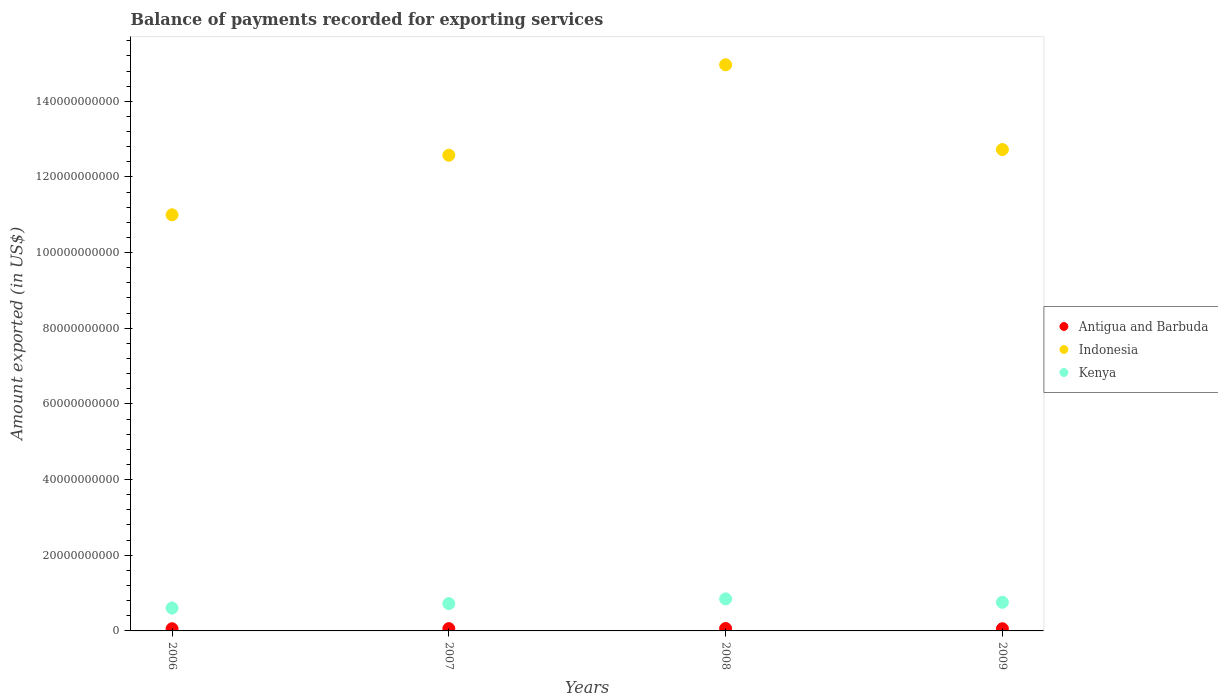How many different coloured dotlines are there?
Your response must be concise. 3. Is the number of dotlines equal to the number of legend labels?
Ensure brevity in your answer.  Yes. What is the amount exported in Indonesia in 2008?
Your answer should be compact. 1.50e+11. Across all years, what is the maximum amount exported in Antigua and Barbuda?
Offer a very short reply. 6.41e+08. Across all years, what is the minimum amount exported in Indonesia?
Provide a short and direct response. 1.10e+11. In which year was the amount exported in Kenya minimum?
Keep it short and to the point. 2006. What is the total amount exported in Kenya in the graph?
Your answer should be compact. 2.93e+1. What is the difference between the amount exported in Antigua and Barbuda in 2007 and that in 2009?
Provide a succinct answer. 3.23e+07. What is the difference between the amount exported in Indonesia in 2009 and the amount exported in Antigua and Barbuda in 2008?
Your answer should be very brief. 1.27e+11. What is the average amount exported in Indonesia per year?
Your response must be concise. 1.28e+11. In the year 2007, what is the difference between the amount exported in Kenya and amount exported in Indonesia?
Provide a succinct answer. -1.19e+11. In how many years, is the amount exported in Indonesia greater than 80000000000 US$?
Ensure brevity in your answer.  4. What is the ratio of the amount exported in Antigua and Barbuda in 2007 to that in 2008?
Your answer should be very brief. 0.95. Is the amount exported in Antigua and Barbuda in 2007 less than that in 2008?
Offer a very short reply. Yes. Is the difference between the amount exported in Kenya in 2006 and 2007 greater than the difference between the amount exported in Indonesia in 2006 and 2007?
Your response must be concise. Yes. What is the difference between the highest and the second highest amount exported in Kenya?
Your response must be concise. 9.00e+08. What is the difference between the highest and the lowest amount exported in Antigua and Barbuda?
Your response must be concise. 6.67e+07. Is it the case that in every year, the sum of the amount exported in Antigua and Barbuda and amount exported in Indonesia  is greater than the amount exported in Kenya?
Give a very brief answer. Yes. Is the amount exported in Kenya strictly less than the amount exported in Indonesia over the years?
Offer a very short reply. Yes. How many dotlines are there?
Keep it short and to the point. 3. How many years are there in the graph?
Keep it short and to the point. 4. Does the graph contain any zero values?
Your answer should be compact. No. Does the graph contain grids?
Keep it short and to the point. No. Where does the legend appear in the graph?
Ensure brevity in your answer.  Center right. What is the title of the graph?
Your answer should be compact. Balance of payments recorded for exporting services. Does "Germany" appear as one of the legend labels in the graph?
Provide a short and direct response. No. What is the label or title of the X-axis?
Provide a succinct answer. Years. What is the label or title of the Y-axis?
Offer a terse response. Amount exported (in US$). What is the Amount exported (in US$) of Antigua and Barbuda in 2006?
Your answer should be very brief. 5.75e+08. What is the Amount exported (in US$) of Indonesia in 2006?
Ensure brevity in your answer.  1.10e+11. What is the Amount exported (in US$) of Kenya in 2006?
Provide a short and direct response. 6.05e+09. What is the Amount exported (in US$) of Antigua and Barbuda in 2007?
Your answer should be compact. 6.07e+08. What is the Amount exported (in US$) of Indonesia in 2007?
Your answer should be very brief. 1.26e+11. What is the Amount exported (in US$) of Kenya in 2007?
Your response must be concise. 7.22e+09. What is the Amount exported (in US$) in Antigua and Barbuda in 2008?
Provide a succinct answer. 6.41e+08. What is the Amount exported (in US$) of Indonesia in 2008?
Provide a short and direct response. 1.50e+11. What is the Amount exported (in US$) of Kenya in 2008?
Provide a short and direct response. 8.47e+09. What is the Amount exported (in US$) in Antigua and Barbuda in 2009?
Make the answer very short. 5.75e+08. What is the Amount exported (in US$) of Indonesia in 2009?
Offer a terse response. 1.27e+11. What is the Amount exported (in US$) in Kenya in 2009?
Your answer should be compact. 7.57e+09. Across all years, what is the maximum Amount exported (in US$) of Antigua and Barbuda?
Keep it short and to the point. 6.41e+08. Across all years, what is the maximum Amount exported (in US$) of Indonesia?
Provide a succinct answer. 1.50e+11. Across all years, what is the maximum Amount exported (in US$) of Kenya?
Ensure brevity in your answer.  8.47e+09. Across all years, what is the minimum Amount exported (in US$) in Antigua and Barbuda?
Your answer should be very brief. 5.75e+08. Across all years, what is the minimum Amount exported (in US$) in Indonesia?
Your answer should be very brief. 1.10e+11. Across all years, what is the minimum Amount exported (in US$) of Kenya?
Offer a terse response. 6.05e+09. What is the total Amount exported (in US$) in Antigua and Barbuda in the graph?
Offer a terse response. 2.40e+09. What is the total Amount exported (in US$) of Indonesia in the graph?
Your answer should be compact. 5.13e+11. What is the total Amount exported (in US$) in Kenya in the graph?
Give a very brief answer. 2.93e+1. What is the difference between the Amount exported (in US$) of Antigua and Barbuda in 2006 and that in 2007?
Offer a very short reply. -3.22e+07. What is the difference between the Amount exported (in US$) of Indonesia in 2006 and that in 2007?
Make the answer very short. -1.57e+1. What is the difference between the Amount exported (in US$) of Kenya in 2006 and that in 2007?
Provide a succinct answer. -1.18e+09. What is the difference between the Amount exported (in US$) in Antigua and Barbuda in 2006 and that in 2008?
Offer a terse response. -6.66e+07. What is the difference between the Amount exported (in US$) in Indonesia in 2006 and that in 2008?
Your answer should be compact. -3.97e+1. What is the difference between the Amount exported (in US$) in Kenya in 2006 and that in 2008?
Offer a terse response. -2.42e+09. What is the difference between the Amount exported (in US$) in Antigua and Barbuda in 2006 and that in 2009?
Ensure brevity in your answer.  1.48e+05. What is the difference between the Amount exported (in US$) in Indonesia in 2006 and that in 2009?
Provide a succinct answer. -1.73e+1. What is the difference between the Amount exported (in US$) of Kenya in 2006 and that in 2009?
Provide a short and direct response. -1.52e+09. What is the difference between the Amount exported (in US$) of Antigua and Barbuda in 2007 and that in 2008?
Ensure brevity in your answer.  -3.44e+07. What is the difference between the Amount exported (in US$) of Indonesia in 2007 and that in 2008?
Offer a very short reply. -2.39e+1. What is the difference between the Amount exported (in US$) in Kenya in 2007 and that in 2008?
Offer a terse response. -1.24e+09. What is the difference between the Amount exported (in US$) in Antigua and Barbuda in 2007 and that in 2009?
Ensure brevity in your answer.  3.23e+07. What is the difference between the Amount exported (in US$) in Indonesia in 2007 and that in 2009?
Offer a very short reply. -1.51e+09. What is the difference between the Amount exported (in US$) of Kenya in 2007 and that in 2009?
Offer a very short reply. -3.44e+08. What is the difference between the Amount exported (in US$) in Antigua and Barbuda in 2008 and that in 2009?
Make the answer very short. 6.67e+07. What is the difference between the Amount exported (in US$) of Indonesia in 2008 and that in 2009?
Provide a short and direct response. 2.24e+1. What is the difference between the Amount exported (in US$) of Kenya in 2008 and that in 2009?
Provide a succinct answer. 9.00e+08. What is the difference between the Amount exported (in US$) of Antigua and Barbuda in 2006 and the Amount exported (in US$) of Indonesia in 2007?
Your answer should be compact. -1.25e+11. What is the difference between the Amount exported (in US$) in Antigua and Barbuda in 2006 and the Amount exported (in US$) in Kenya in 2007?
Your answer should be very brief. -6.65e+09. What is the difference between the Amount exported (in US$) of Indonesia in 2006 and the Amount exported (in US$) of Kenya in 2007?
Offer a very short reply. 1.03e+11. What is the difference between the Amount exported (in US$) of Antigua and Barbuda in 2006 and the Amount exported (in US$) of Indonesia in 2008?
Make the answer very short. -1.49e+11. What is the difference between the Amount exported (in US$) of Antigua and Barbuda in 2006 and the Amount exported (in US$) of Kenya in 2008?
Keep it short and to the point. -7.89e+09. What is the difference between the Amount exported (in US$) in Indonesia in 2006 and the Amount exported (in US$) in Kenya in 2008?
Your answer should be very brief. 1.02e+11. What is the difference between the Amount exported (in US$) in Antigua and Barbuda in 2006 and the Amount exported (in US$) in Indonesia in 2009?
Keep it short and to the point. -1.27e+11. What is the difference between the Amount exported (in US$) in Antigua and Barbuda in 2006 and the Amount exported (in US$) in Kenya in 2009?
Your answer should be compact. -6.99e+09. What is the difference between the Amount exported (in US$) of Indonesia in 2006 and the Amount exported (in US$) of Kenya in 2009?
Make the answer very short. 1.02e+11. What is the difference between the Amount exported (in US$) of Antigua and Barbuda in 2007 and the Amount exported (in US$) of Indonesia in 2008?
Your answer should be compact. -1.49e+11. What is the difference between the Amount exported (in US$) of Antigua and Barbuda in 2007 and the Amount exported (in US$) of Kenya in 2008?
Provide a succinct answer. -7.86e+09. What is the difference between the Amount exported (in US$) of Indonesia in 2007 and the Amount exported (in US$) of Kenya in 2008?
Ensure brevity in your answer.  1.17e+11. What is the difference between the Amount exported (in US$) of Antigua and Barbuda in 2007 and the Amount exported (in US$) of Indonesia in 2009?
Give a very brief answer. -1.27e+11. What is the difference between the Amount exported (in US$) in Antigua and Barbuda in 2007 and the Amount exported (in US$) in Kenya in 2009?
Your response must be concise. -6.96e+09. What is the difference between the Amount exported (in US$) in Indonesia in 2007 and the Amount exported (in US$) in Kenya in 2009?
Your answer should be compact. 1.18e+11. What is the difference between the Amount exported (in US$) in Antigua and Barbuda in 2008 and the Amount exported (in US$) in Indonesia in 2009?
Offer a very short reply. -1.27e+11. What is the difference between the Amount exported (in US$) in Antigua and Barbuda in 2008 and the Amount exported (in US$) in Kenya in 2009?
Provide a short and direct response. -6.93e+09. What is the difference between the Amount exported (in US$) in Indonesia in 2008 and the Amount exported (in US$) in Kenya in 2009?
Ensure brevity in your answer.  1.42e+11. What is the average Amount exported (in US$) of Antigua and Barbuda per year?
Offer a terse response. 6.00e+08. What is the average Amount exported (in US$) in Indonesia per year?
Keep it short and to the point. 1.28e+11. What is the average Amount exported (in US$) of Kenya per year?
Provide a short and direct response. 7.33e+09. In the year 2006, what is the difference between the Amount exported (in US$) in Antigua and Barbuda and Amount exported (in US$) in Indonesia?
Make the answer very short. -1.09e+11. In the year 2006, what is the difference between the Amount exported (in US$) of Antigua and Barbuda and Amount exported (in US$) of Kenya?
Give a very brief answer. -5.47e+09. In the year 2006, what is the difference between the Amount exported (in US$) in Indonesia and Amount exported (in US$) in Kenya?
Your response must be concise. 1.04e+11. In the year 2007, what is the difference between the Amount exported (in US$) in Antigua and Barbuda and Amount exported (in US$) in Indonesia?
Make the answer very short. -1.25e+11. In the year 2007, what is the difference between the Amount exported (in US$) of Antigua and Barbuda and Amount exported (in US$) of Kenya?
Your response must be concise. -6.62e+09. In the year 2007, what is the difference between the Amount exported (in US$) of Indonesia and Amount exported (in US$) of Kenya?
Provide a short and direct response. 1.19e+11. In the year 2008, what is the difference between the Amount exported (in US$) in Antigua and Barbuda and Amount exported (in US$) in Indonesia?
Your response must be concise. -1.49e+11. In the year 2008, what is the difference between the Amount exported (in US$) in Antigua and Barbuda and Amount exported (in US$) in Kenya?
Offer a terse response. -7.83e+09. In the year 2008, what is the difference between the Amount exported (in US$) in Indonesia and Amount exported (in US$) in Kenya?
Offer a terse response. 1.41e+11. In the year 2009, what is the difference between the Amount exported (in US$) in Antigua and Barbuda and Amount exported (in US$) in Indonesia?
Provide a short and direct response. -1.27e+11. In the year 2009, what is the difference between the Amount exported (in US$) in Antigua and Barbuda and Amount exported (in US$) in Kenya?
Provide a short and direct response. -6.99e+09. In the year 2009, what is the difference between the Amount exported (in US$) of Indonesia and Amount exported (in US$) of Kenya?
Give a very brief answer. 1.20e+11. What is the ratio of the Amount exported (in US$) of Antigua and Barbuda in 2006 to that in 2007?
Ensure brevity in your answer.  0.95. What is the ratio of the Amount exported (in US$) of Indonesia in 2006 to that in 2007?
Make the answer very short. 0.87. What is the ratio of the Amount exported (in US$) of Kenya in 2006 to that in 2007?
Your answer should be very brief. 0.84. What is the ratio of the Amount exported (in US$) in Antigua and Barbuda in 2006 to that in 2008?
Offer a terse response. 0.9. What is the ratio of the Amount exported (in US$) of Indonesia in 2006 to that in 2008?
Provide a short and direct response. 0.73. What is the ratio of the Amount exported (in US$) in Kenya in 2006 to that in 2008?
Provide a short and direct response. 0.71. What is the ratio of the Amount exported (in US$) of Antigua and Barbuda in 2006 to that in 2009?
Provide a succinct answer. 1. What is the ratio of the Amount exported (in US$) of Indonesia in 2006 to that in 2009?
Keep it short and to the point. 0.86. What is the ratio of the Amount exported (in US$) of Kenya in 2006 to that in 2009?
Give a very brief answer. 0.8. What is the ratio of the Amount exported (in US$) of Antigua and Barbuda in 2007 to that in 2008?
Your answer should be very brief. 0.95. What is the ratio of the Amount exported (in US$) in Indonesia in 2007 to that in 2008?
Keep it short and to the point. 0.84. What is the ratio of the Amount exported (in US$) in Kenya in 2007 to that in 2008?
Your response must be concise. 0.85. What is the ratio of the Amount exported (in US$) in Antigua and Barbuda in 2007 to that in 2009?
Your answer should be very brief. 1.06. What is the ratio of the Amount exported (in US$) in Kenya in 2007 to that in 2009?
Your response must be concise. 0.95. What is the ratio of the Amount exported (in US$) of Antigua and Barbuda in 2008 to that in 2009?
Make the answer very short. 1.12. What is the ratio of the Amount exported (in US$) of Indonesia in 2008 to that in 2009?
Your response must be concise. 1.18. What is the ratio of the Amount exported (in US$) of Kenya in 2008 to that in 2009?
Your answer should be very brief. 1.12. What is the difference between the highest and the second highest Amount exported (in US$) in Antigua and Barbuda?
Provide a succinct answer. 3.44e+07. What is the difference between the highest and the second highest Amount exported (in US$) of Indonesia?
Offer a terse response. 2.24e+1. What is the difference between the highest and the second highest Amount exported (in US$) of Kenya?
Your response must be concise. 9.00e+08. What is the difference between the highest and the lowest Amount exported (in US$) in Antigua and Barbuda?
Your answer should be compact. 6.67e+07. What is the difference between the highest and the lowest Amount exported (in US$) in Indonesia?
Offer a terse response. 3.97e+1. What is the difference between the highest and the lowest Amount exported (in US$) in Kenya?
Offer a very short reply. 2.42e+09. 